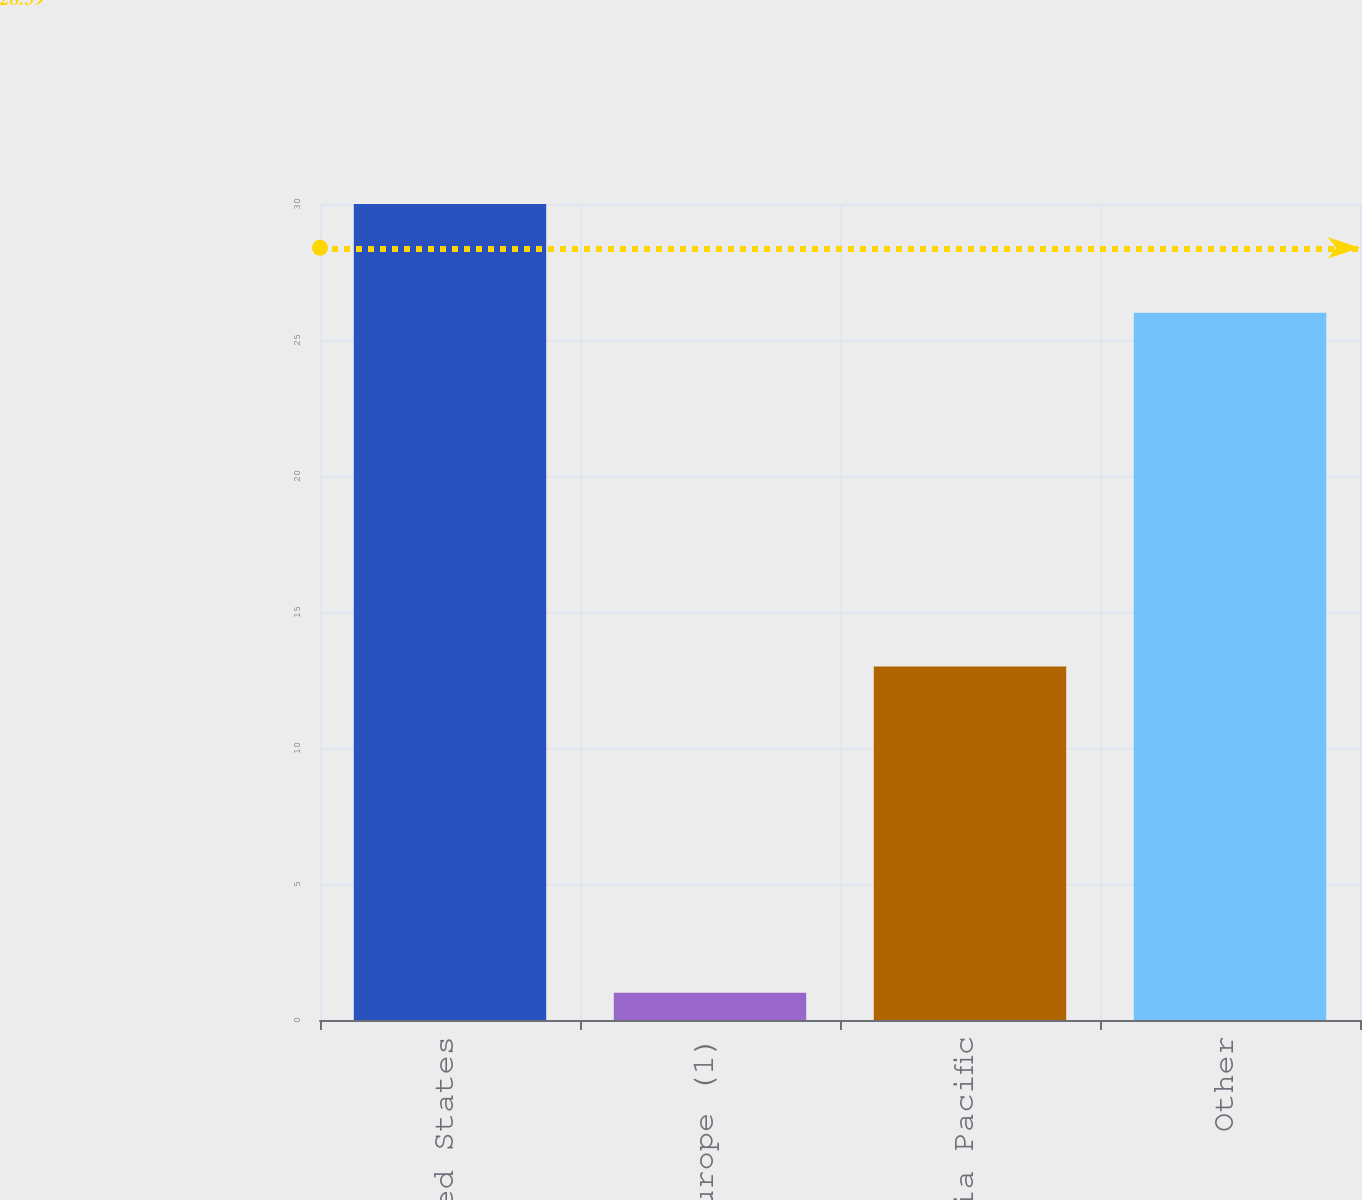Convert chart to OTSL. <chart><loc_0><loc_0><loc_500><loc_500><bar_chart><fcel>United States<fcel>Europe (1)<fcel>Asia Pacific<fcel>Other<nl><fcel>30<fcel>1<fcel>13<fcel>26<nl></chart> 